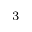<formula> <loc_0><loc_0><loc_500><loc_500>^ { 3 }</formula> 